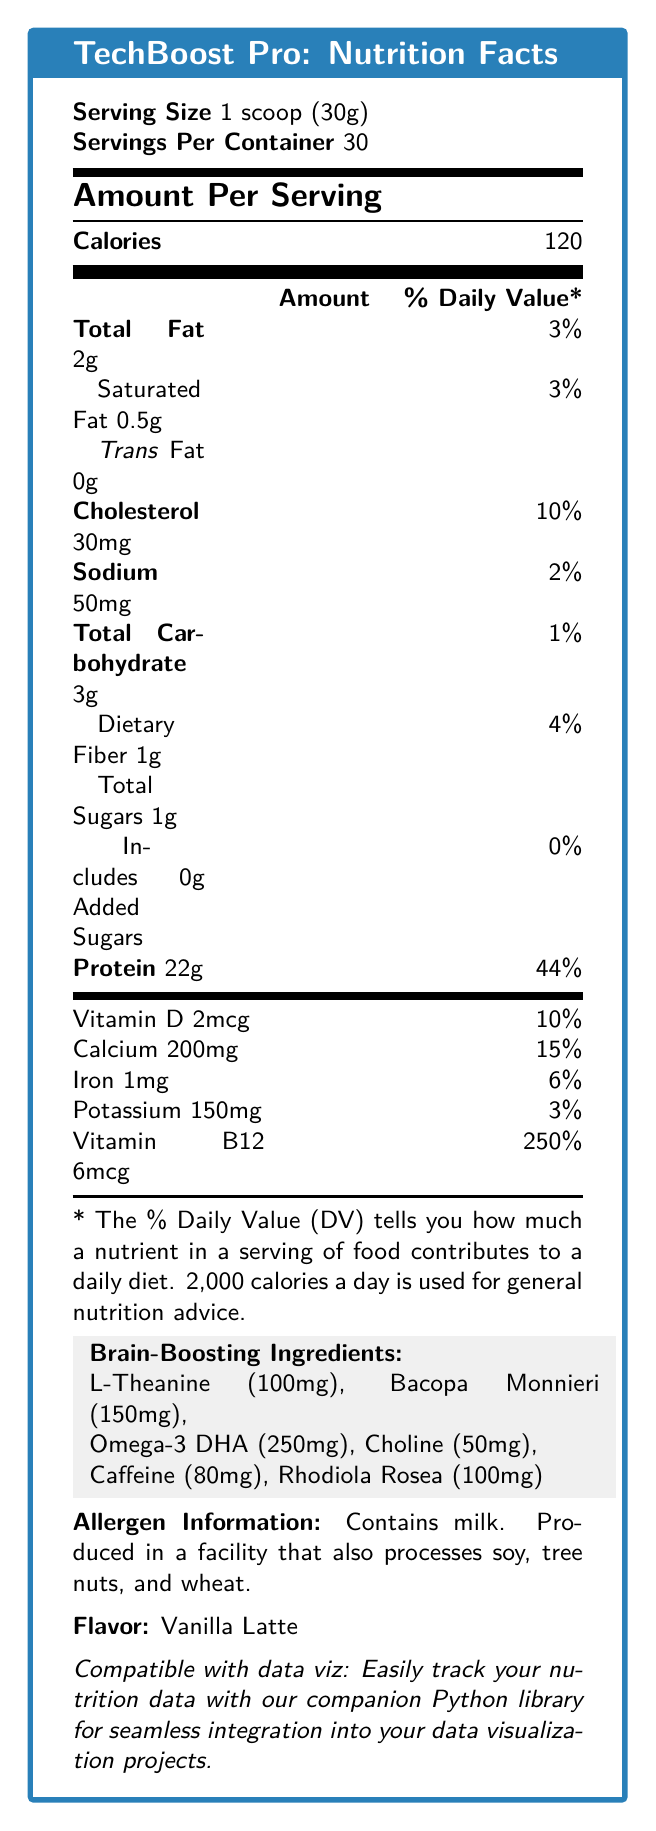what is the serving size of TechBoost Pro? The serving size is explicitly mentioned at the beginning of the document as "Serving Size: 1 scoop (30g)".
Answer: 1 scoop (30g) how many calories are in one serving? The document states "Calories: 120" in the Amount Per Serving section.
Answer: 120 what is the total fat content per serving? Under the nutrition facts, it lists the total fat as 2g.
Answer: 2g how much protein is in each serving? The document indicates that protein amount per serving is 22g with a daily value of 44%.
Answer: 22g what is the daily value percentage of Vitamin D per serving? The nutrition label shows that the daily value percentage for Vitamin D is 10%.
Answer: 10% which ingredient supports energy metabolism and nervous system function? A. L-Theanine B. Vitamin B12 C. Choline D. Bacopa Monnieri The document indicates that Vitamin B12 supports energy metabolism and nervous system function with a daily value of 250%.
Answer: B which brain-boosting ingredient is known for promoting relaxation and focus? A. Omega-3 DHA B. L-Theanine C. Rhodiola Rosea D. Bacopa Monnieri According to the document, L-Theanine promotes relaxation and focus.
Answer: B is this product suitable for someone allergic to milk? The allergen information clearly states that it contains milk.
Answer: No summarize the main idea of the document. The document provides detailed information about the TechBoost Pro protein shake's nutritional content and its benefits for cognitive function, making it a suitable choice for tech professionals.
Answer: The document features the nutritional information for TechBoost Pro: Cognitive Enhancement Protein Shake, including serving size, calories, macronutrients, micronutrients, and brain-boosting ingredients. It highlights elements particularly beneficial to tech professionals, like caffeine and Vitamin B12, and provides instructions for use and allergen information. The product is presented as compatible with data visualization projects. what is the flavor of the TechBoost Pro shake? The document states the flavor as Vanilla Latte.
Answer: Vanilla Latte how should the product be stored after opening? The storage instructions specify that the product should be refrigerated after opening.
Answer: Refrigerate after opening how many servings are in one container of TechBoost Pro? The document lists the servings per container as 30.
Answer: 30 how much caffeine is in each serving? The section on brain-boosting ingredients identifies each serving contains 80mg of caffeine.
Answer: 80mg what daily value percentage does calcium contribute per serving? Calcium per serving contributes 15% of the daily value according to the nutritional information.
Answer: 15% does the protein shake contain any trans fats? The document explicitly states that the trans fat content is 0g.
Answer: No how can you integrate the nutritional data into your data visualization projects? The document mentions that it is compatible with data visualization through a companion Python library.
Answer: Using a companion Python library what is the omega-3 DHA content per serving? The brain-boosting ingredients section lists the Omega-3 DHA content as 250mg per serving.
Answer: 250mg how should you consume the TechBoost Pro protein shake for best results? The recommended use section specifies these instructions for optimal consumption.
Answer: Mix 1 scoop with 8-10 oz of cold water or milk. Best consumed in the morning or before mentally demanding tasks. do the added sugars in the product contribute to the daily value percentage? The document states that added sugars amount to 0g, with a daily value percentage of 0%.
Answer: No what benefit does Bacopa Monnieri provide? Bacopa Monnieri, listed in the brain-boosting ingredients, is noted for enhancing memory and cognitive function.
Answer: Enhances memory and cognitive function does the product contain soy, tree nuts, or wheat? While the document states the product is produced in a facility that processes soy, tree nuts, and wheat, it does not specify if the product itself contains these allergens.
Answer: Cannot be determined 